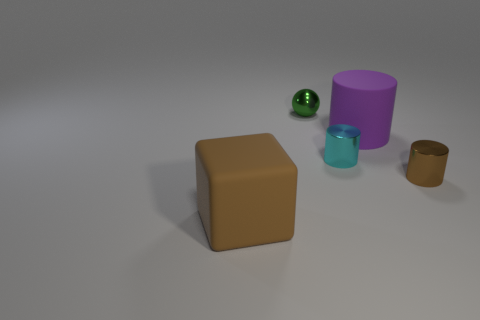What is the purple thing made of?
Provide a short and direct response. Rubber. Is the material of the cyan thing the same as the big purple object?
Ensure brevity in your answer.  No. How many matte objects are cyan objects or big green objects?
Your answer should be very brief. 0. There is a rubber thing that is behind the matte block; what shape is it?
Offer a very short reply. Cylinder. There is a green thing that is the same material as the small brown thing; what size is it?
Give a very brief answer. Small. What shape is the object that is on the left side of the tiny cyan shiny cylinder and behind the large brown rubber block?
Offer a terse response. Sphere. There is a thing left of the small green sphere; does it have the same color as the tiny ball?
Your answer should be very brief. No. Does the big rubber thing right of the large brown block have the same shape as the brown thing on the right side of the rubber block?
Provide a succinct answer. Yes. What size is the metallic sphere behind the small cyan metal cylinder?
Give a very brief answer. Small. What is the size of the rubber object behind the matte thing that is on the left side of the green metal sphere?
Your response must be concise. Large. 